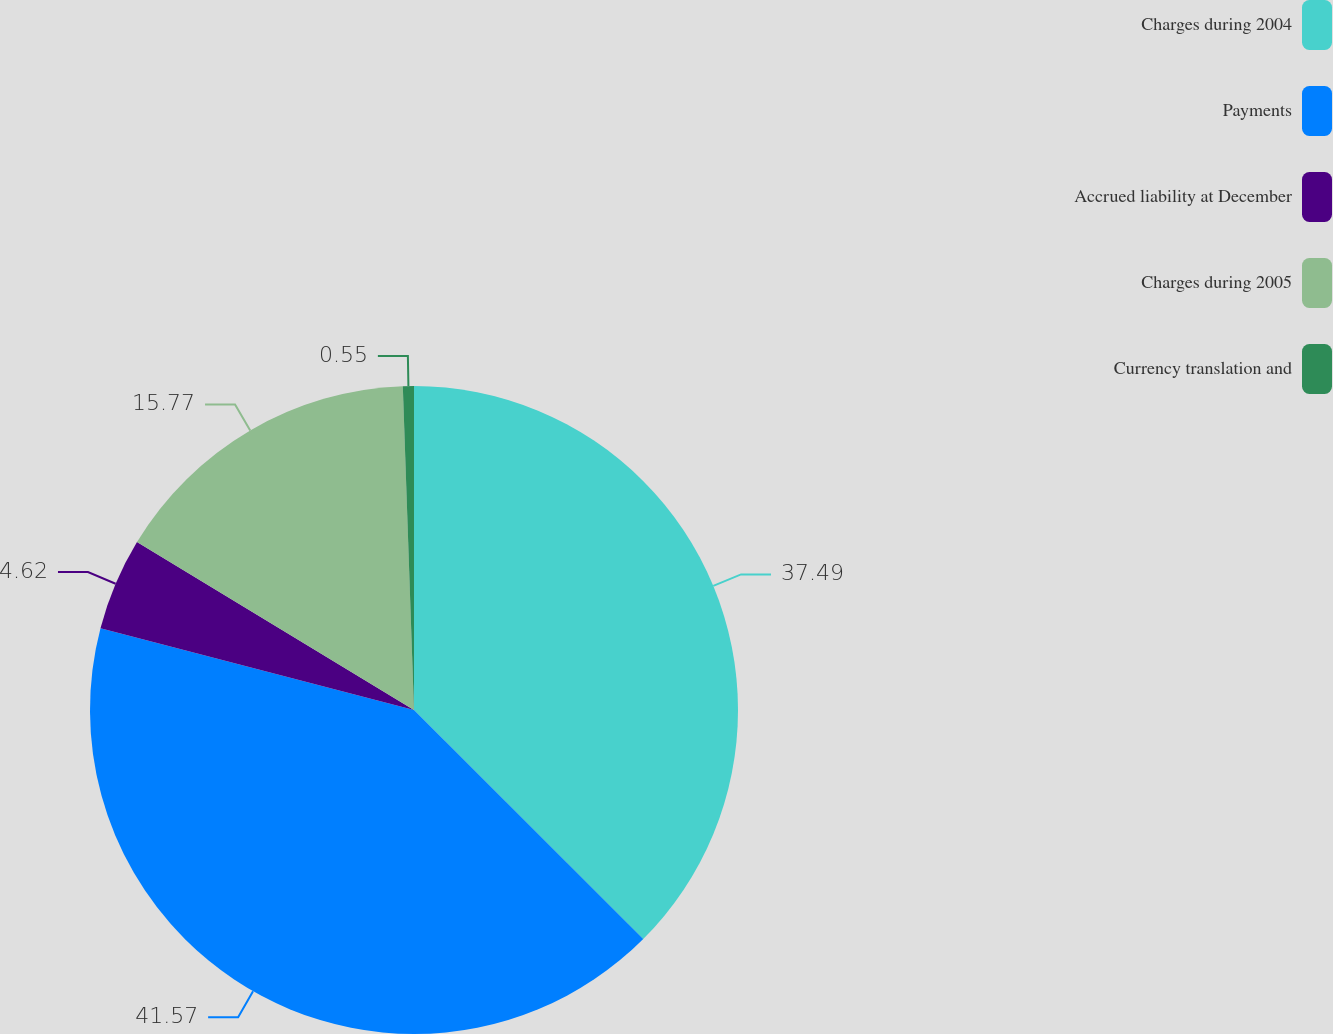<chart> <loc_0><loc_0><loc_500><loc_500><pie_chart><fcel>Charges during 2004<fcel>Payments<fcel>Accrued liability at December<fcel>Charges during 2005<fcel>Currency translation and<nl><fcel>37.49%<fcel>41.57%<fcel>4.62%<fcel>15.77%<fcel>0.55%<nl></chart> 